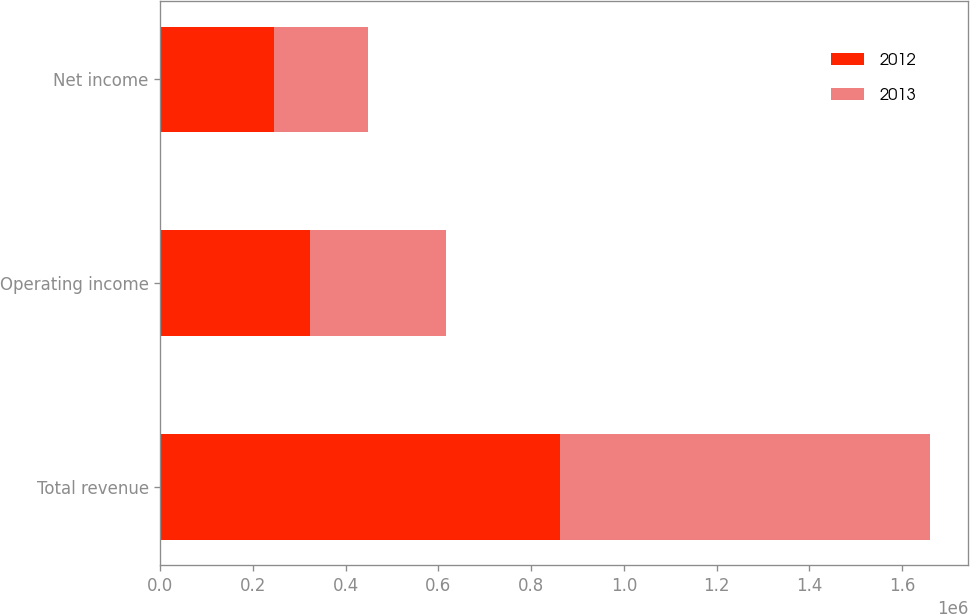Convert chart. <chart><loc_0><loc_0><loc_500><loc_500><stacked_bar_chart><ecel><fcel>Total revenue<fcel>Operating income<fcel>Net income<nl><fcel>2012<fcel>861260<fcel>321863<fcel>245327<nl><fcel>2013<fcel>798018<fcel>294253<fcel>203483<nl></chart> 